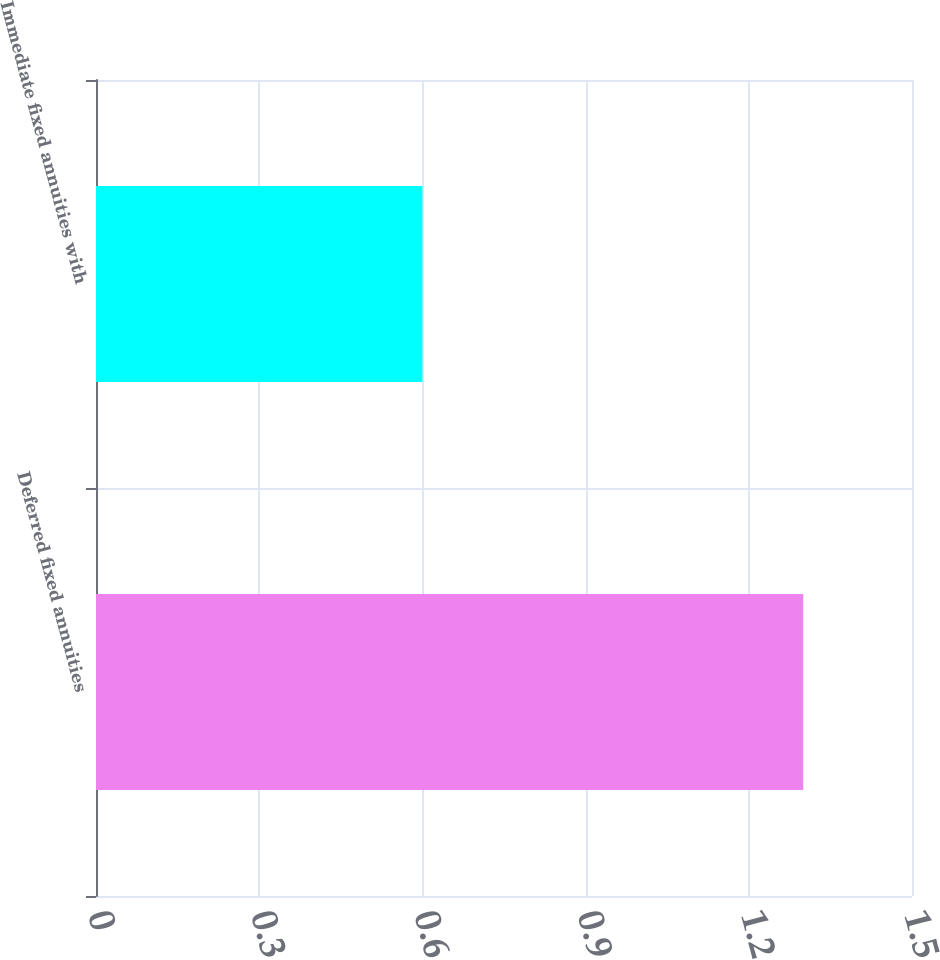<chart> <loc_0><loc_0><loc_500><loc_500><bar_chart><fcel>Deferred fixed annuities<fcel>Immediate fixed annuities with<nl><fcel>1.3<fcel>0.6<nl></chart> 